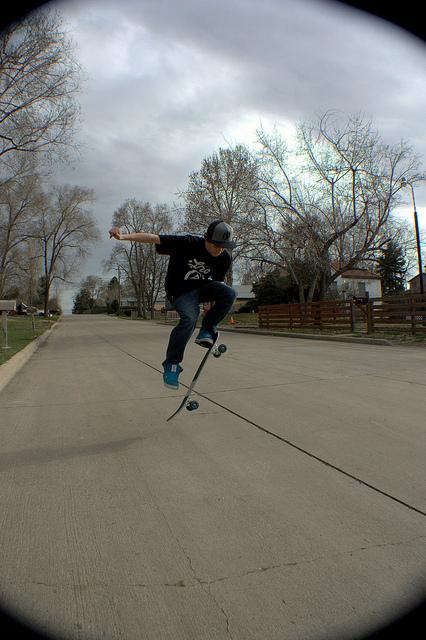Overcast or sunny?
Write a very short answer. Overcast. Does this look like a skate park on the road?
Keep it brief. Road. What is the boy riding on?
Quick response, please. Skateboard. 